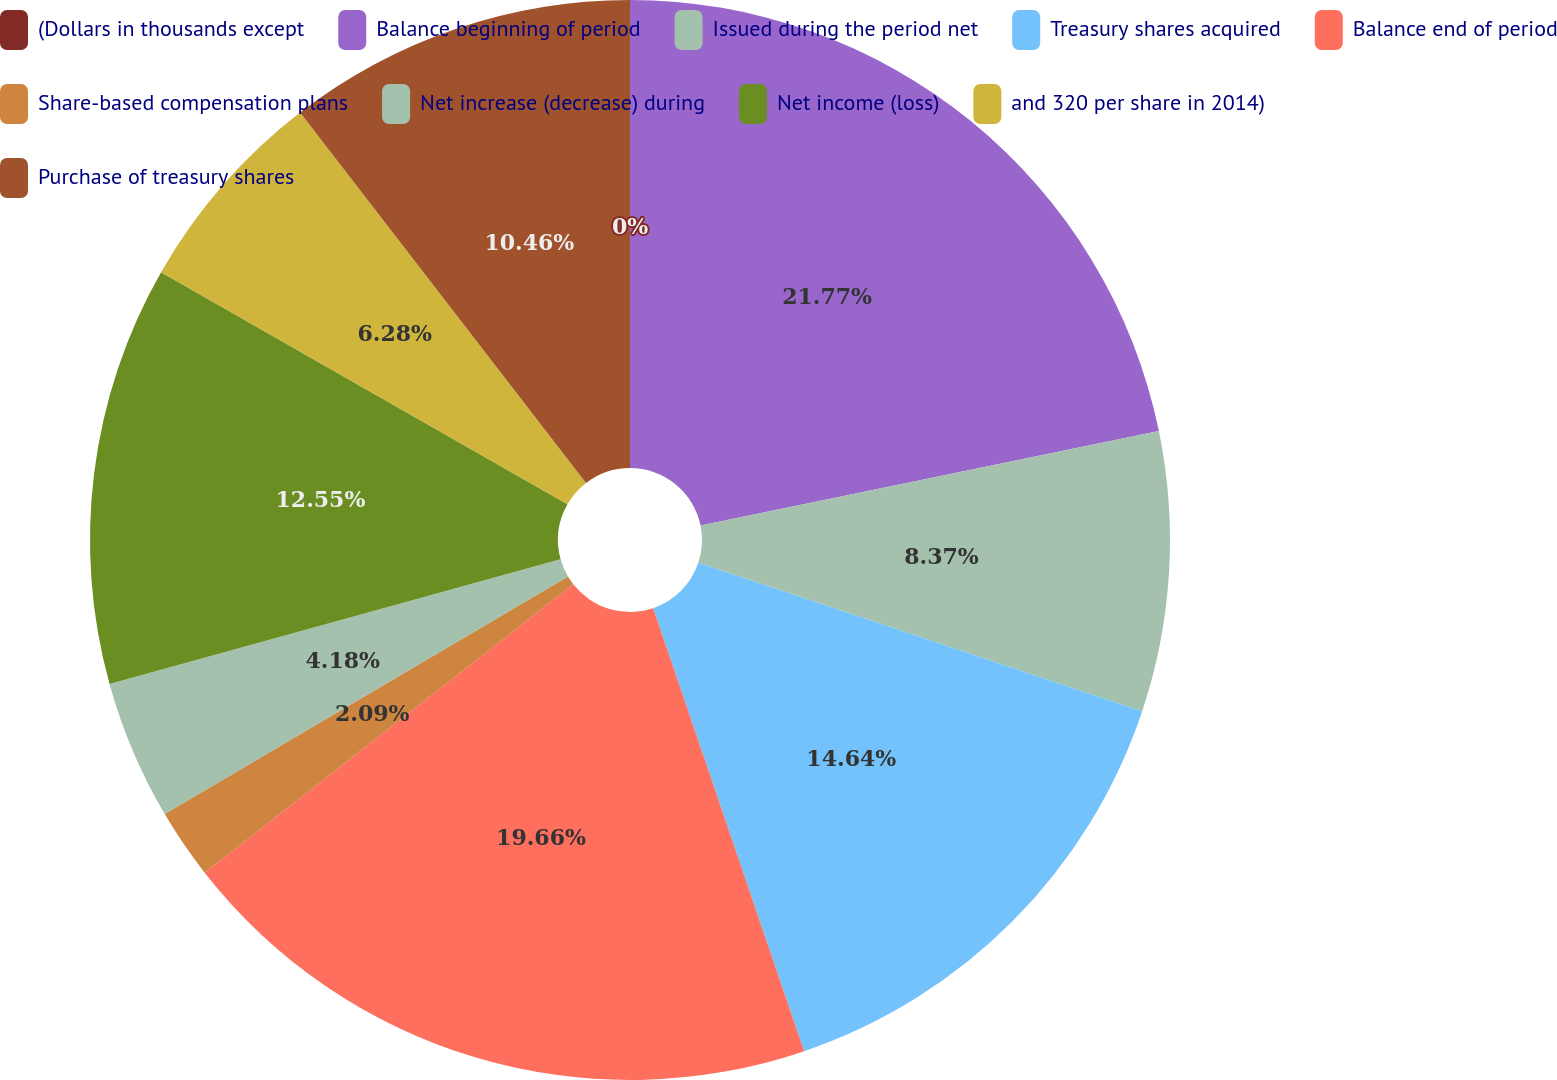Convert chart. <chart><loc_0><loc_0><loc_500><loc_500><pie_chart><fcel>(Dollars in thousands except<fcel>Balance beginning of period<fcel>Issued during the period net<fcel>Treasury shares acquired<fcel>Balance end of period<fcel>Share-based compensation plans<fcel>Net increase (decrease) during<fcel>Net income (loss)<fcel>and 320 per share in 2014)<fcel>Purchase of treasury shares<nl><fcel>0.0%<fcel>21.76%<fcel>8.37%<fcel>14.64%<fcel>19.66%<fcel>2.09%<fcel>4.18%<fcel>12.55%<fcel>6.28%<fcel>10.46%<nl></chart> 